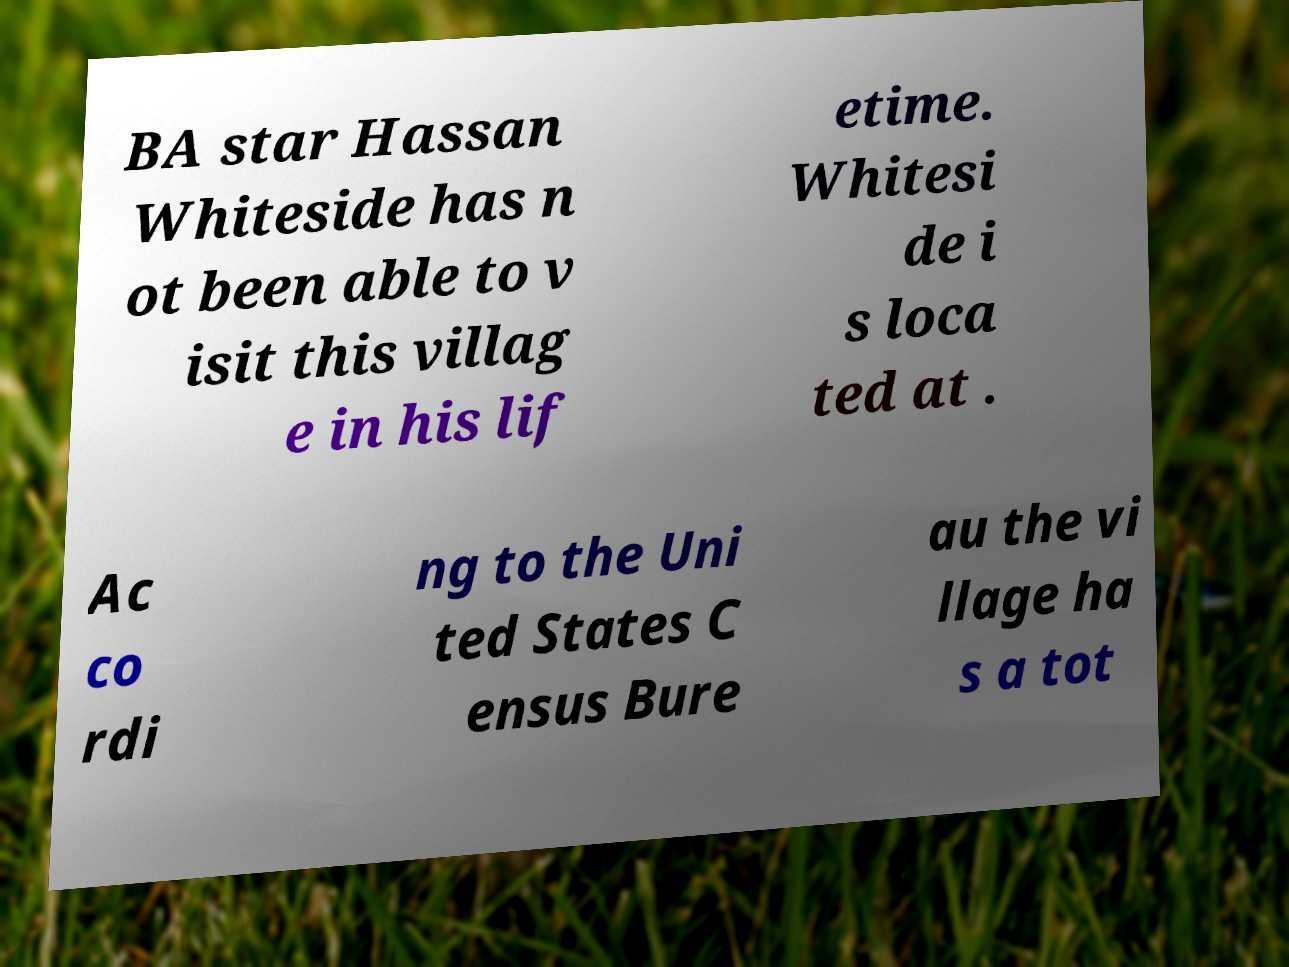Please identify and transcribe the text found in this image. BA star Hassan Whiteside has n ot been able to v isit this villag e in his lif etime. Whitesi de i s loca ted at . Ac co rdi ng to the Uni ted States C ensus Bure au the vi llage ha s a tot 